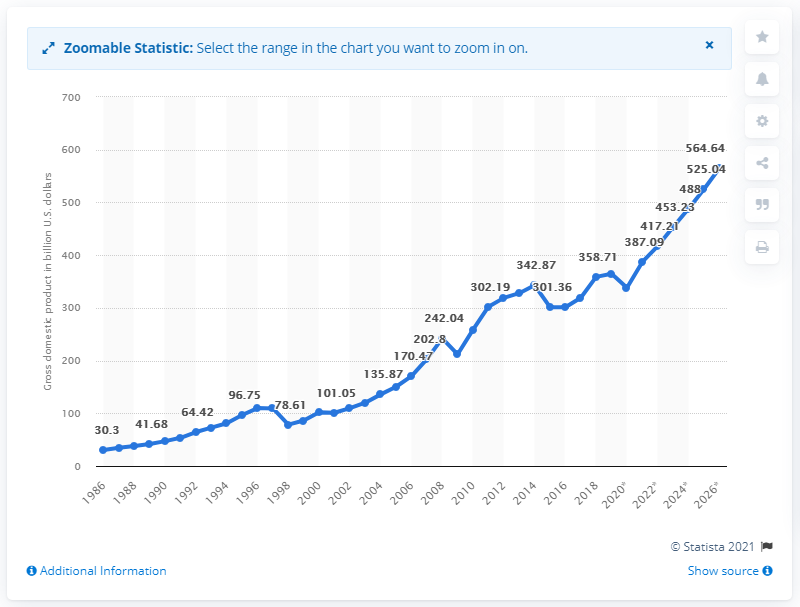Identify some key points in this picture. In 2019, Malaysia's Gross Domestic Product (GDP) was 364.68. 